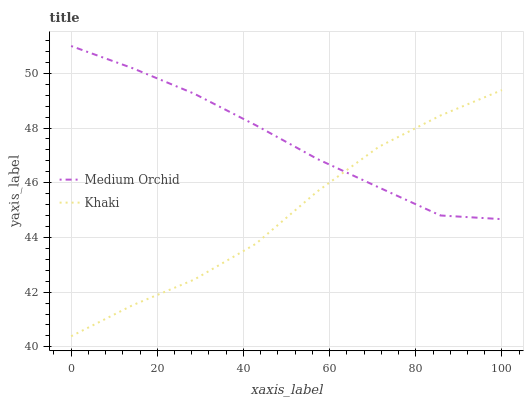Does Khaki have the maximum area under the curve?
Answer yes or no. No. Is Khaki the smoothest?
Answer yes or no. No. Does Khaki have the highest value?
Answer yes or no. No. 